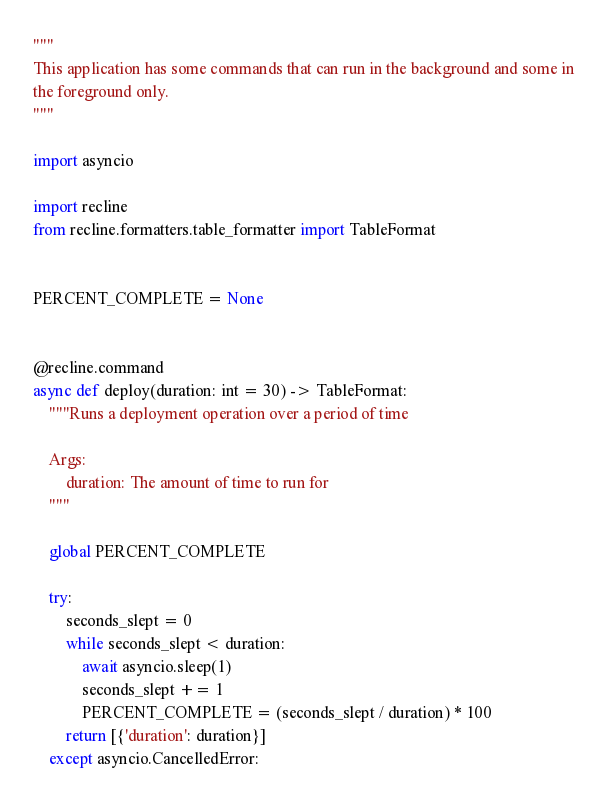Convert code to text. <code><loc_0><loc_0><loc_500><loc_500><_Python_>"""
This application has some commands that can run in the background and some in
the foreground only.
"""

import asyncio

import recline
from recline.formatters.table_formatter import TableFormat


PERCENT_COMPLETE = None


@recline.command
async def deploy(duration: int = 30) -> TableFormat:
    """Runs a deployment operation over a period of time

    Args:
        duration: The amount of time to run for
    """

    global PERCENT_COMPLETE

    try:
        seconds_slept = 0
        while seconds_slept < duration:
            await asyncio.sleep(1)
            seconds_slept += 1
            PERCENT_COMPLETE = (seconds_slept / duration) * 100
        return [{'duration': duration}]
    except asyncio.CancelledError:</code> 